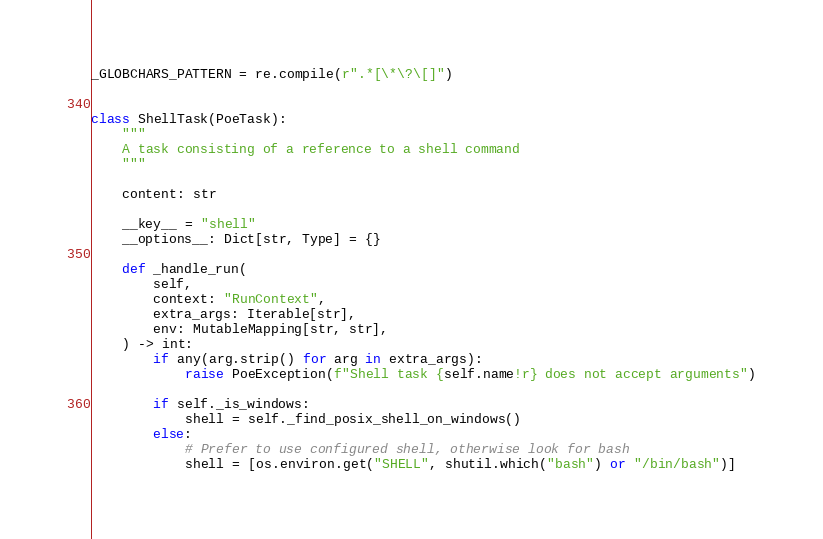Convert code to text. <code><loc_0><loc_0><loc_500><loc_500><_Python_>_GLOBCHARS_PATTERN = re.compile(r".*[\*\?\[]")


class ShellTask(PoeTask):
    """
    A task consisting of a reference to a shell command
    """

    content: str

    __key__ = "shell"
    __options__: Dict[str, Type] = {}

    def _handle_run(
        self,
        context: "RunContext",
        extra_args: Iterable[str],
        env: MutableMapping[str, str],
    ) -> int:
        if any(arg.strip() for arg in extra_args):
            raise PoeException(f"Shell task {self.name!r} does not accept arguments")

        if self._is_windows:
            shell = self._find_posix_shell_on_windows()
        else:
            # Prefer to use configured shell, otherwise look for bash
            shell = [os.environ.get("SHELL", shutil.which("bash") or "/bin/bash")]
</code> 